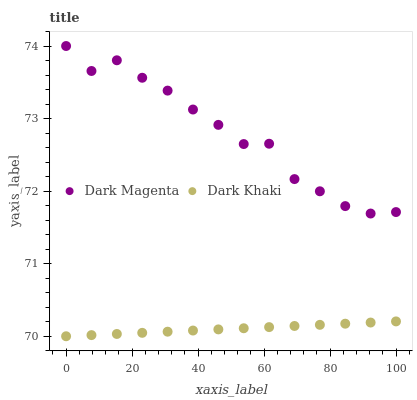Does Dark Khaki have the minimum area under the curve?
Answer yes or no. Yes. Does Dark Magenta have the maximum area under the curve?
Answer yes or no. Yes. Does Dark Magenta have the minimum area under the curve?
Answer yes or no. No. Is Dark Khaki the smoothest?
Answer yes or no. Yes. Is Dark Magenta the roughest?
Answer yes or no. Yes. Is Dark Magenta the smoothest?
Answer yes or no. No. Does Dark Khaki have the lowest value?
Answer yes or no. Yes. Does Dark Magenta have the lowest value?
Answer yes or no. No. Does Dark Magenta have the highest value?
Answer yes or no. Yes. Is Dark Khaki less than Dark Magenta?
Answer yes or no. Yes. Is Dark Magenta greater than Dark Khaki?
Answer yes or no. Yes. Does Dark Khaki intersect Dark Magenta?
Answer yes or no. No. 